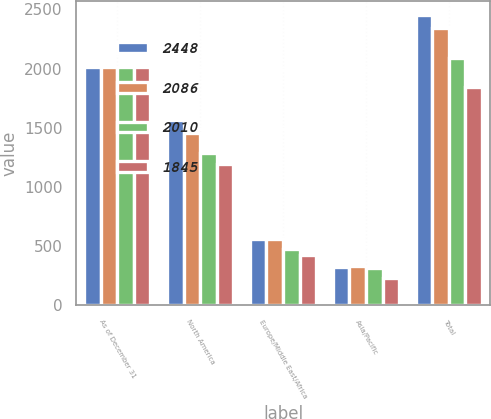<chart> <loc_0><loc_0><loc_500><loc_500><stacked_bar_chart><ecel><fcel>As of December 31<fcel>North America<fcel>Europe/Middle East/Africa<fcel>Asia/Pacific<fcel>Total<nl><fcel>2448<fcel>2014<fcel>1568<fcel>559<fcel>321<fcel>2448<nl><fcel>2086<fcel>2013<fcel>1456<fcel>560<fcel>329<fcel>2345<nl><fcel>2010<fcel>2012<fcel>1288<fcel>480<fcel>318<fcel>2086<nl><fcel>1845<fcel>2011<fcel>1190<fcel>428<fcel>227<fcel>1845<nl></chart> 